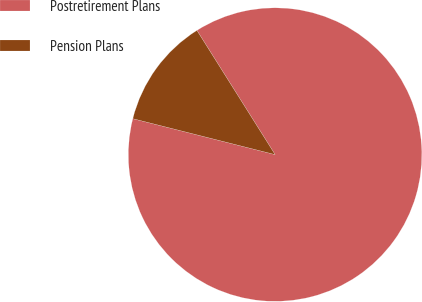<chart> <loc_0><loc_0><loc_500><loc_500><pie_chart><fcel>Postretirement Plans<fcel>Pension Plans<nl><fcel>87.88%<fcel>12.12%<nl></chart> 